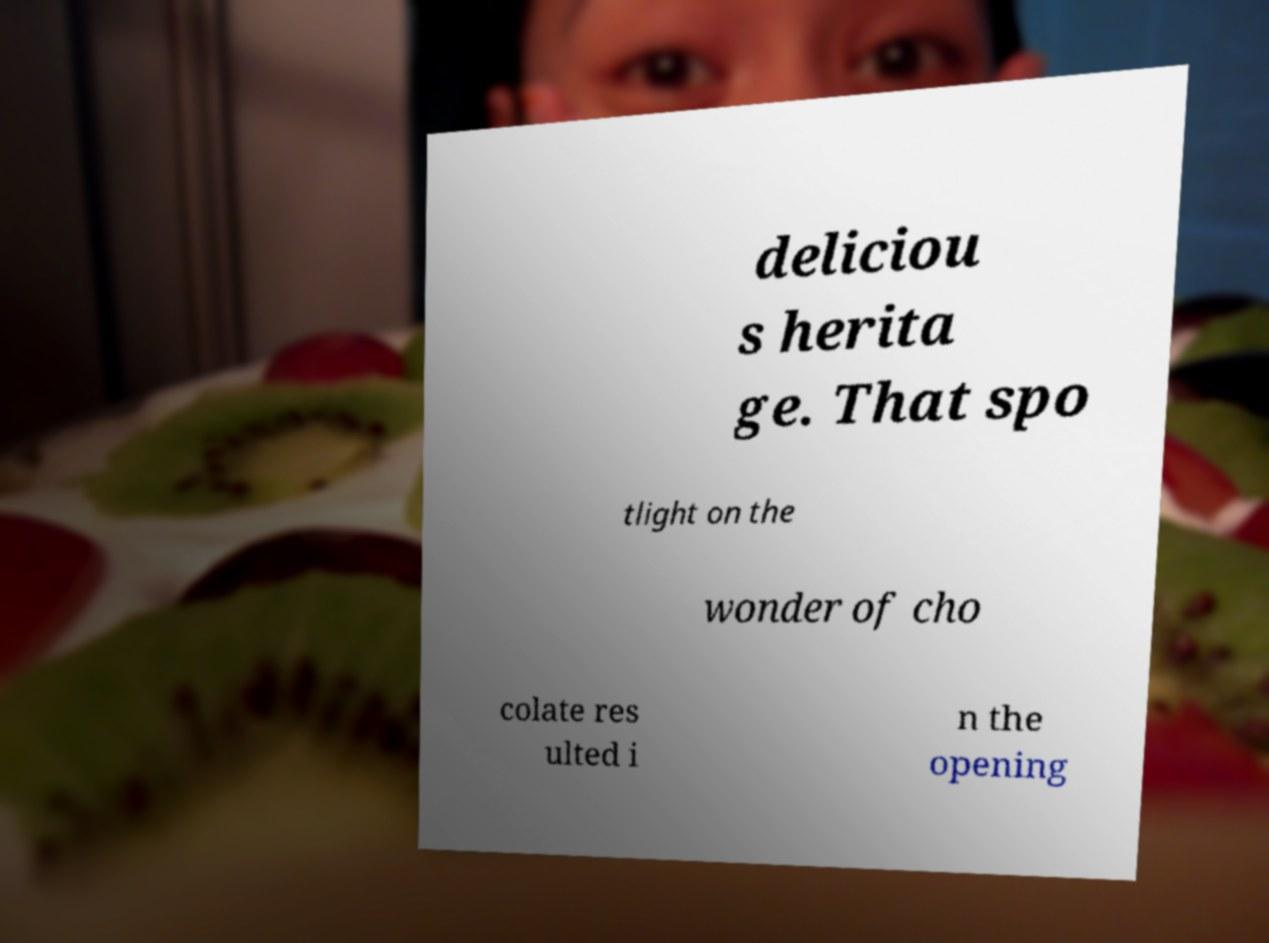Can you read and provide the text displayed in the image?This photo seems to have some interesting text. Can you extract and type it out for me? deliciou s herita ge. That spo tlight on the wonder of cho colate res ulted i n the opening 